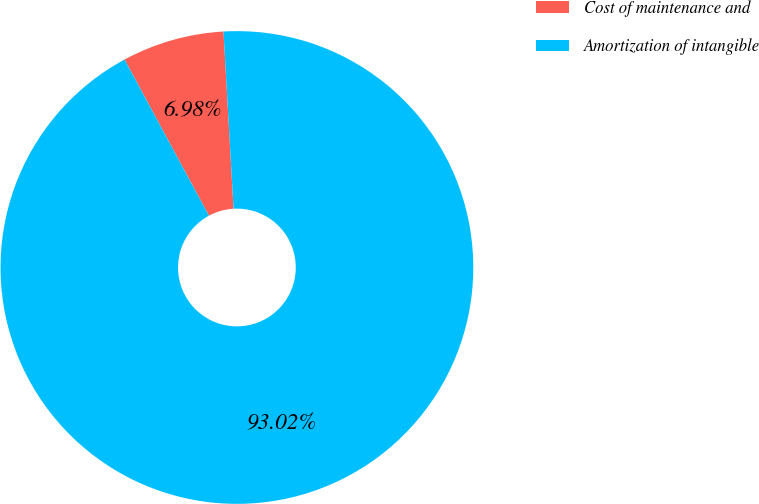<chart> <loc_0><loc_0><loc_500><loc_500><pie_chart><fcel>Cost of maintenance and<fcel>Amortization of intangible<nl><fcel>6.98%<fcel>93.02%<nl></chart> 